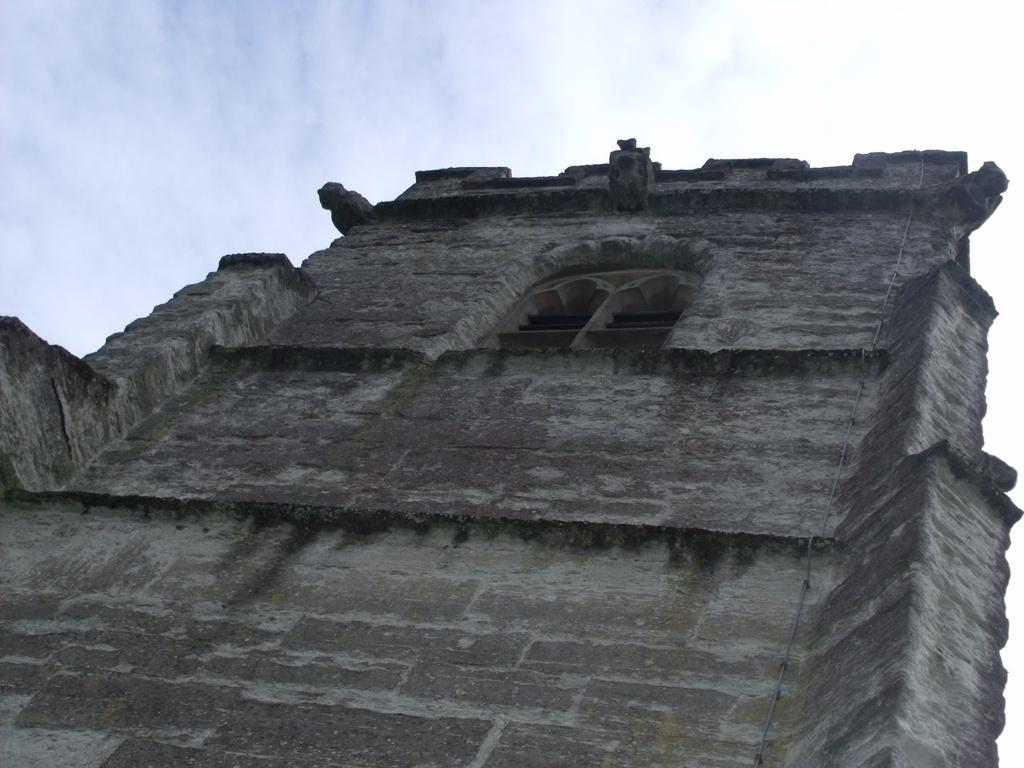What can be seen at the top of the image? The sky is visible towards the top of the image. What is located towards the bottom of the image? There is a building towards the bottom of the image. Can you identify any specific features of the building? Unfortunately, the provided facts do not mention any specific features of the building. Is there any opening in the building visible in the image? Yes, there is a window in the image. How many goldfish can be seen swimming in the ocean in the image? There is no ocean or goldfish present in the image. What type of cabbage is growing near the window in the image? There is no cabbage visible in the image. 